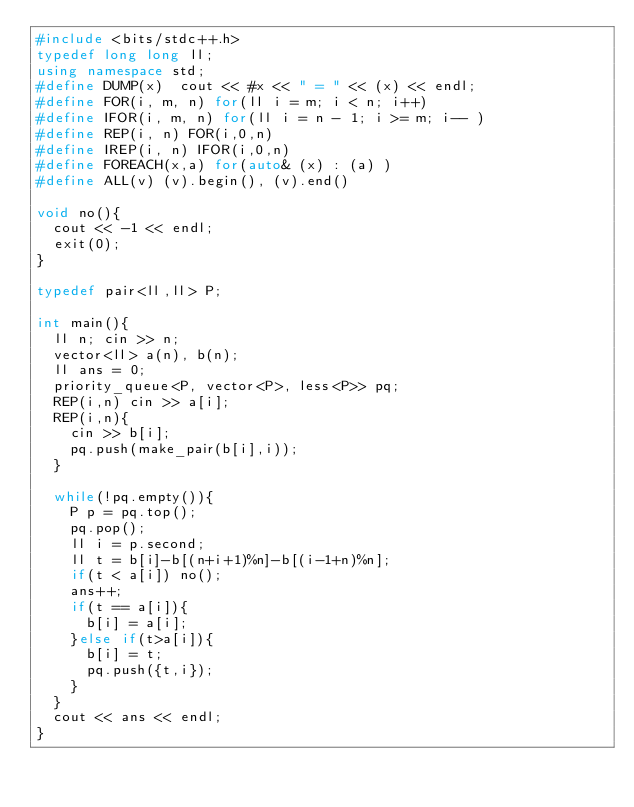Convert code to text. <code><loc_0><loc_0><loc_500><loc_500><_C++_>#include <bits/stdc++.h>
typedef long long ll;
using namespace std;
#define DUMP(x)  cout << #x << " = " << (x) << endl;
#define FOR(i, m, n) for(ll i = m; i < n; i++)
#define IFOR(i, m, n) for(ll i = n - 1; i >= m; i-- )
#define REP(i, n) FOR(i,0,n)
#define IREP(i, n) IFOR(i,0,n)
#define FOREACH(x,a) for(auto& (x) : (a) )
#define ALL(v) (v).begin(), (v).end()

void no(){
  cout << -1 << endl;
  exit(0);
}

typedef pair<ll,ll> P;

int main(){
  ll n; cin >> n;
  vector<ll> a(n), b(n);
  ll ans = 0;
  priority_queue<P, vector<P>, less<P>> pq;
  REP(i,n) cin >> a[i];
  REP(i,n){
    cin >> b[i];
    pq.push(make_pair(b[i],i));
  }

  while(!pq.empty()){
    P p = pq.top();
    pq.pop();
    ll i = p.second;
    ll t = b[i]-b[(n+i+1)%n]-b[(i-1+n)%n];
    if(t < a[i]) no();
    ans++;
    if(t == a[i]){
      b[i] = a[i];
    }else if(t>a[i]){
      b[i] = t;
      pq.push({t,i});
    }
  }
  cout << ans << endl;
}

</code> 